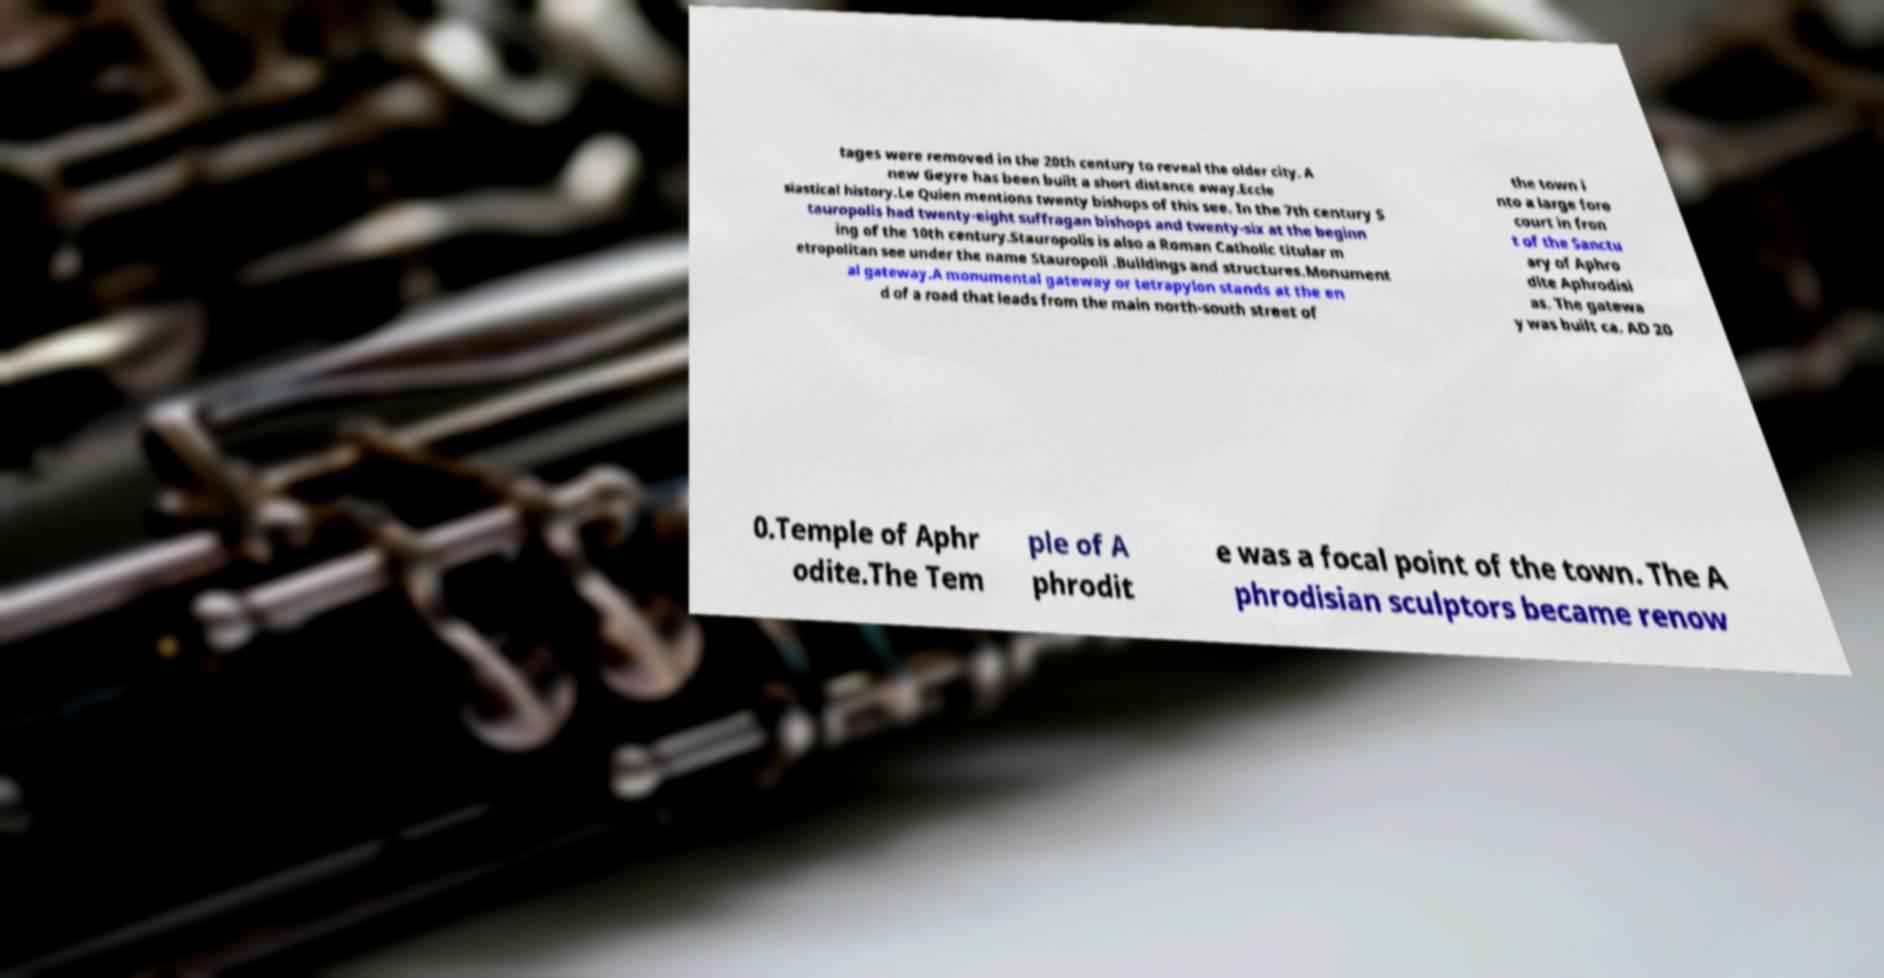For documentation purposes, I need the text within this image transcribed. Could you provide that? tages were removed in the 20th century to reveal the older city. A new Geyre has been built a short distance away.Eccle siastical history.Le Quien mentions twenty bishops of this see. In the 7th century S tauropolis had twenty-eight suffragan bishops and twenty-six at the beginn ing of the 10th century.Stauropolis is also a Roman Catholic titular m etropolitan see under the name Stauropoli .Buildings and structures.Monument al gateway.A monumental gateway or tetrapylon stands at the en d of a road that leads from the main north-south street of the town i nto a large fore court in fron t of the Sanctu ary of Aphro dite Aphrodisi as. The gatewa y was built ca. AD 20 0.Temple of Aphr odite.The Tem ple of A phrodit e was a focal point of the town. The A phrodisian sculptors became renow 